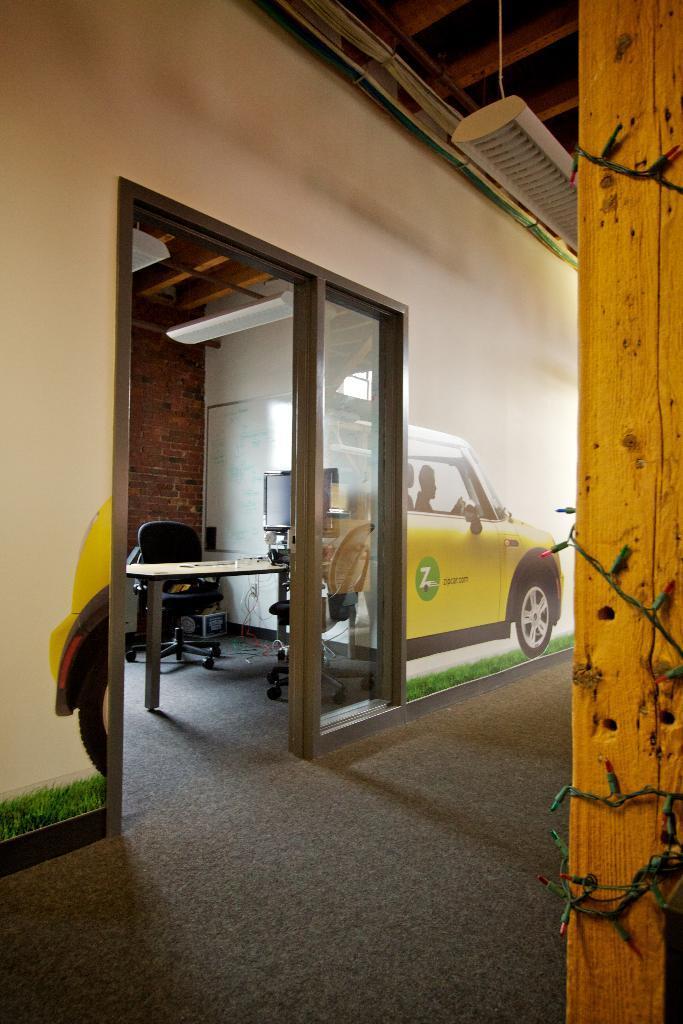Please provide a concise description of this image. This image is clicked inside a room. To the right there is a wooden pillar. There are fairy lights to the pillar. There is a light hanging to the ceiling. There is a glass door to the wall. On the other side of the door there is a table. There are chairs beside the table. There is a monitor on the table. There is a picture of a car on the wall. 